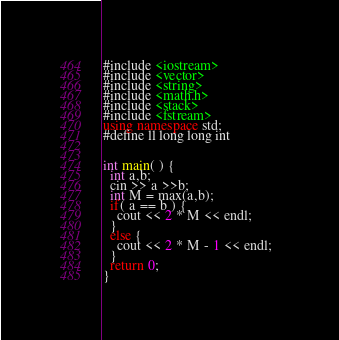Convert code to text. <code><loc_0><loc_0><loc_500><loc_500><_C++_>#include <iostream> 
#include <vector>
#include <string>
#include <math.h>
#include <stack>
#include <fstream>
using namespace std;
#define ll long long int


int main( ) {
  int a,b;
  cin >> a >>b;
  int M = max(a,b);
  if( a == b ) {
    cout << 2 * M << endl;  
  }
  else {
    cout << 2 * M - 1 << endl;  
  }
  return 0;
}
</code> 